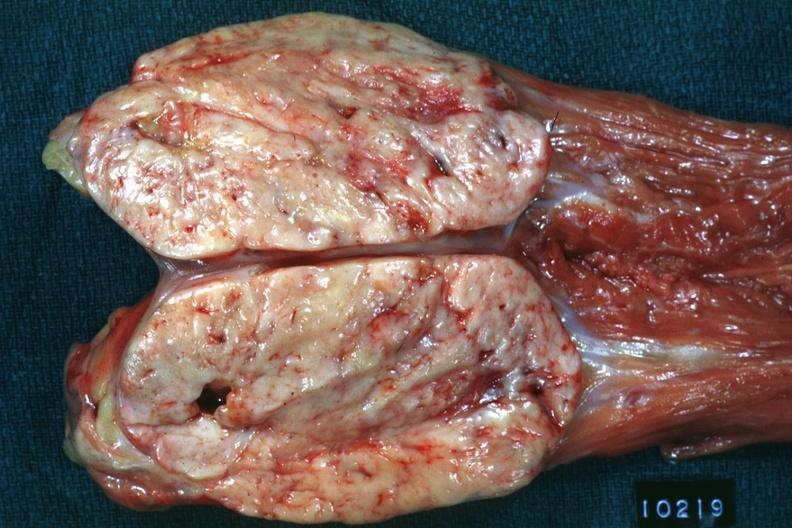s peritoneum present?
Answer the question using a single word or phrase. Yes 